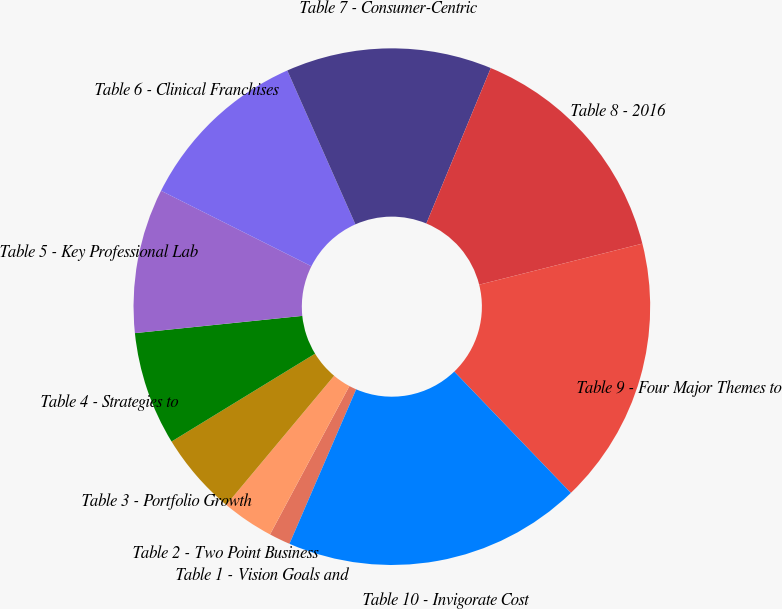<chart> <loc_0><loc_0><loc_500><loc_500><pie_chart><fcel>Table 1 - Vision Goals and<fcel>Table 2 - Two Point Business<fcel>Table 3 - Portfolio Growth<fcel>Table 4 - Strategies to<fcel>Table 5 - Key Professional Lab<fcel>Table 6 - Clinical Franchises<fcel>Table 7 - Consumer-Centric<fcel>Table 8 - 2016<fcel>Table 9 - Four Major Themes to<fcel>Table 10 - Invigorate Cost<nl><fcel>1.33%<fcel>3.26%<fcel>5.18%<fcel>7.11%<fcel>9.04%<fcel>10.96%<fcel>12.89%<fcel>14.82%<fcel>16.74%<fcel>18.67%<nl></chart> 